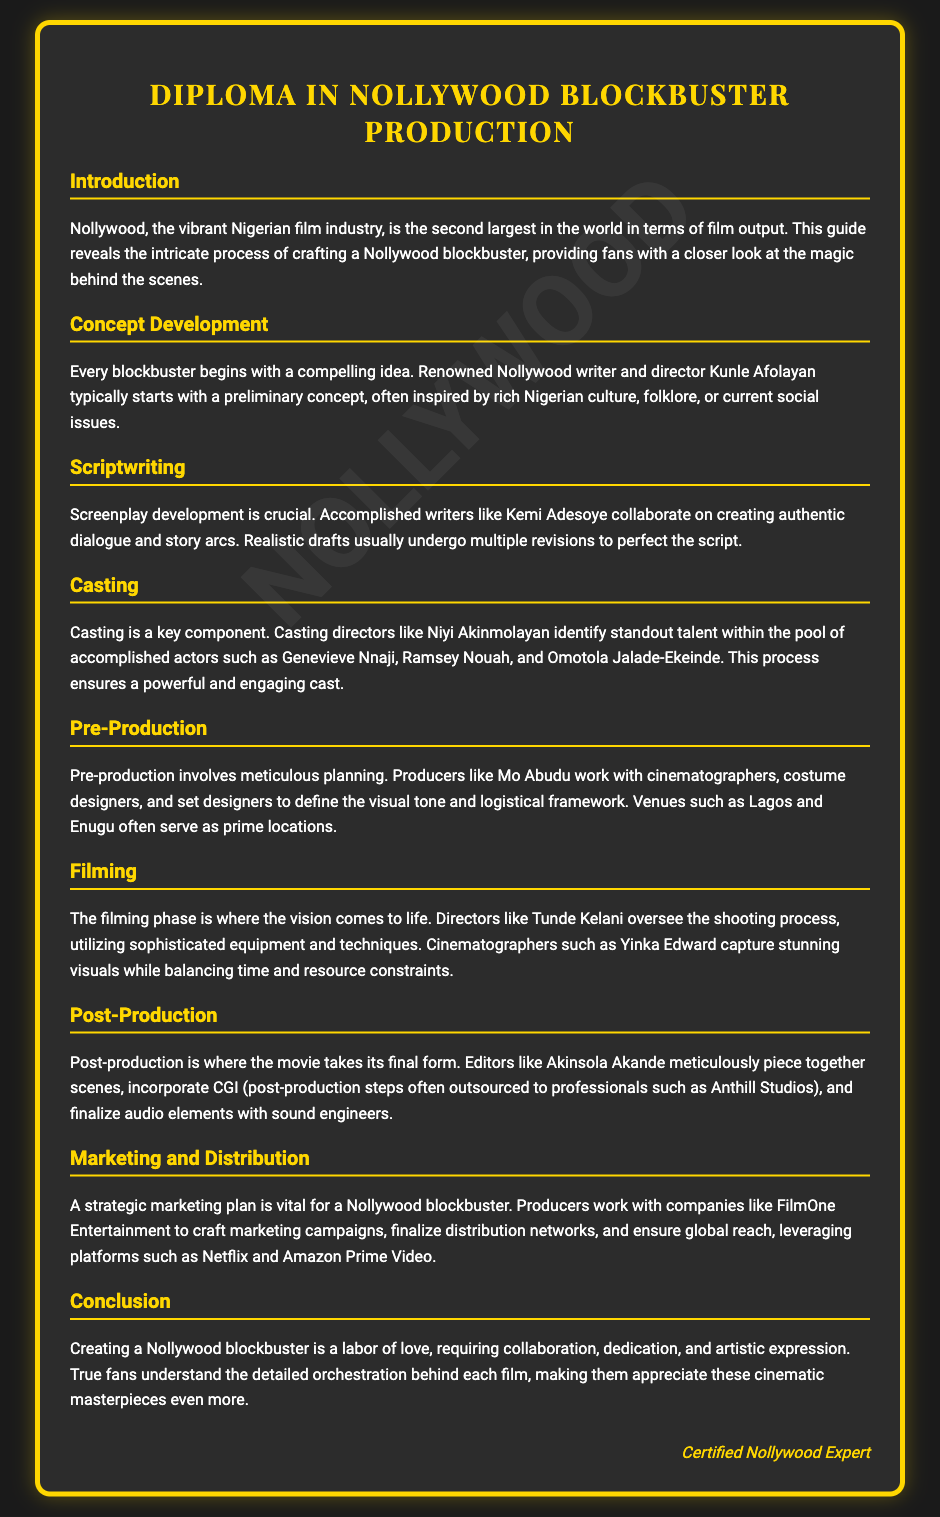What is the title of the diploma? The title of the diploma is clearly stated at the top of the document.
Answer: Diploma in Nollywood Blockbuster Production Who typically starts with a preliminary concept? The document mentions a renowned Nollywood writer and director responsible for initial concepts.
Answer: Kunle Afolayan What phase involves meticulous planning? This phase is highlighted as crucial for defining the visual tone and logistical framework.
Answer: Pre-Production Which company is mentioned for crafting marketing campaigns? The document specifies a producer's partnership for marketing strategies.
Answer: FilmOne Entertainment Who oversees the shooting process? The document identifies a director in charge during filming.
Answer: Tunde Kelani What role does Kemi Adesoye play in the scriptwriting process? This person's involvement in screenplay development is detailed in the document.
Answer: Writer What is the primary setting for filming mentioned in the document? The document lists locations that are commonly used for filming.
Answer: Lagos and Enugu Which studio is mentioned for CGI in post-production? The document cites a specific studio known for this service.
Answer: Anthill Studios How does the document describe the creation of a Nollywood blockbuster? This phrase captures the essence of the collaborative effort involved.
Answer: A labor of love 